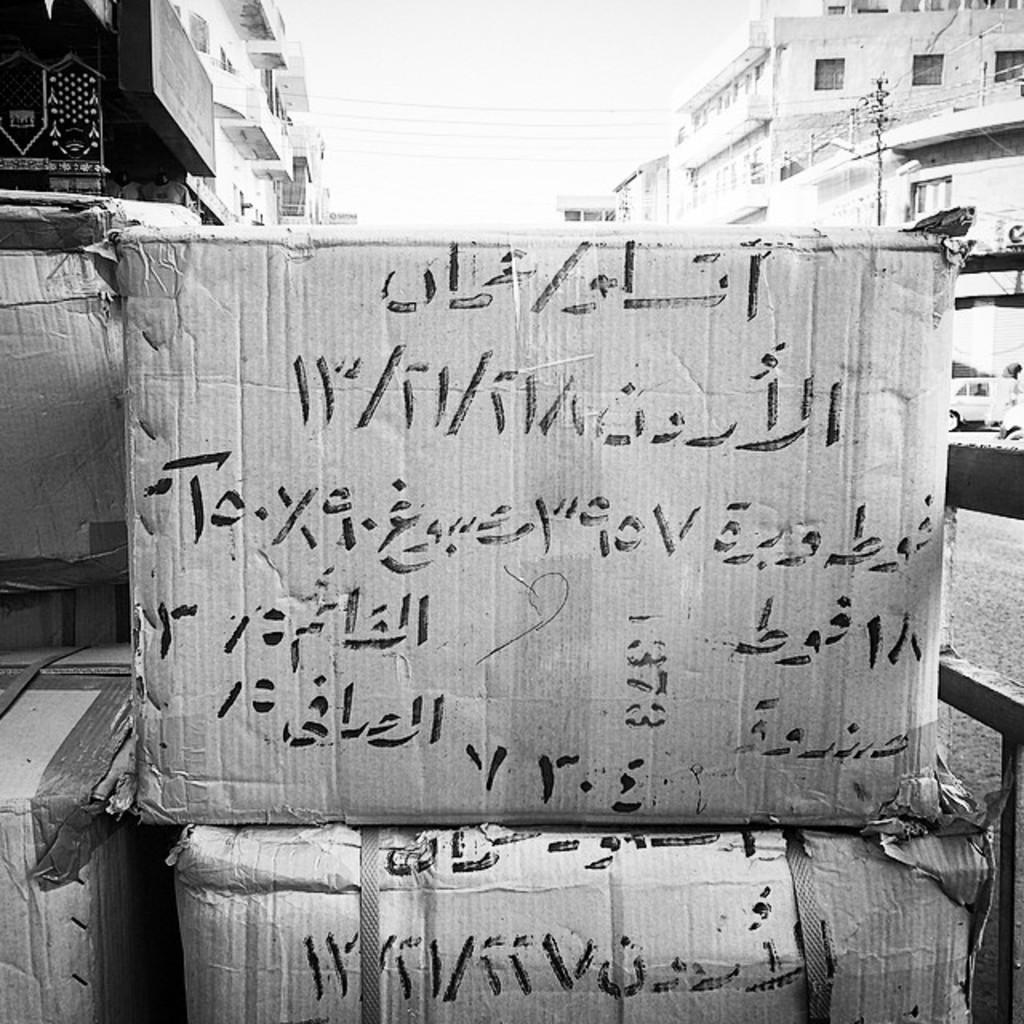What type of objects are present in the image? There are carton boxes in the image. What information is provided on the boxes? There is text written on the boxes. What can be seen in the distance in the image? There are buildings in the background of the image. What part of the natural environment is visible in the image? The sky is visible in the background of the image. What type of amusement can be seen in the image? There is no amusement present in the image; it features carton boxes with text and a background of buildings and the sky. What type of property is depicted in the image? The image does not depict any specific property; it shows carton boxes, text, buildings, and the sky. 